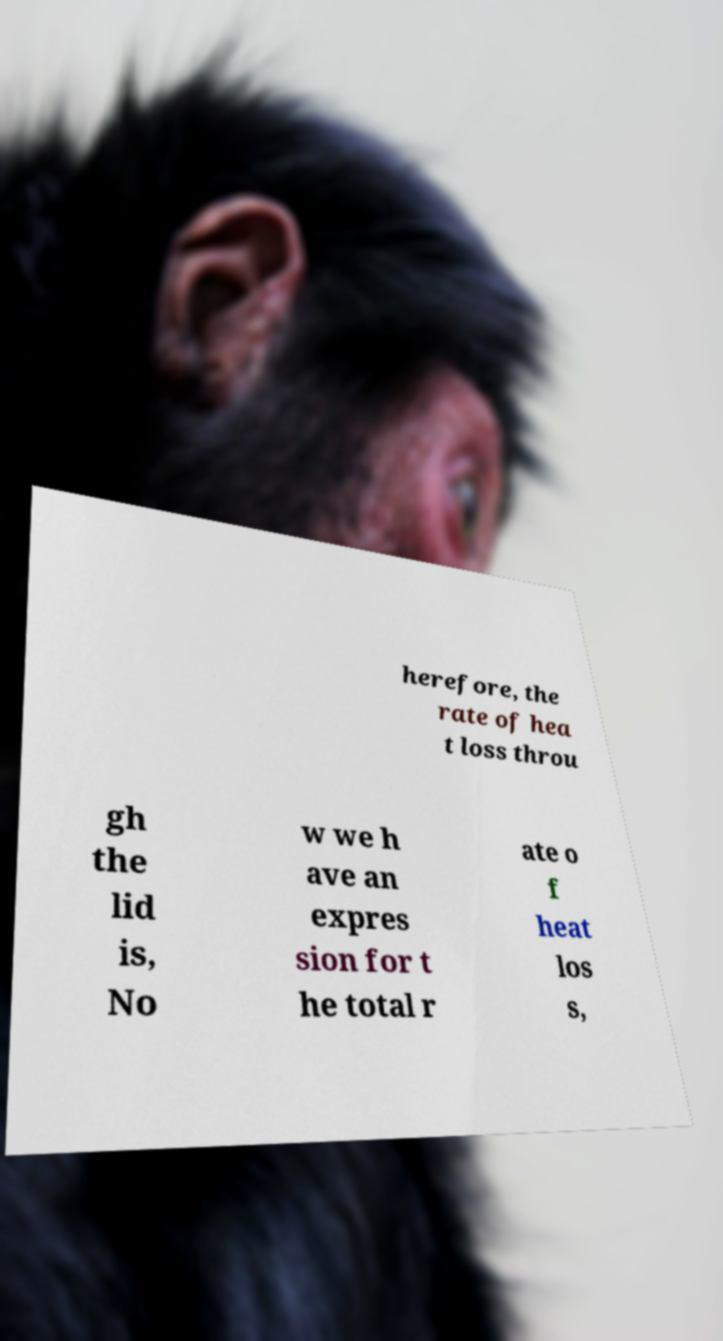I need the written content from this picture converted into text. Can you do that? herefore, the rate of hea t loss throu gh the lid is, No w we h ave an expres sion for t he total r ate o f heat los s, 